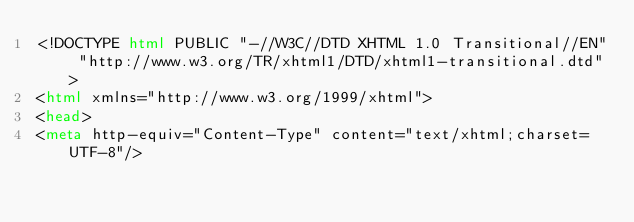Convert code to text. <code><loc_0><loc_0><loc_500><loc_500><_HTML_><!DOCTYPE html PUBLIC "-//W3C//DTD XHTML 1.0 Transitional//EN" "http://www.w3.org/TR/xhtml1/DTD/xhtml1-transitional.dtd">
<html xmlns="http://www.w3.org/1999/xhtml">
<head>
<meta http-equiv="Content-Type" content="text/xhtml;charset=UTF-8"/></code> 